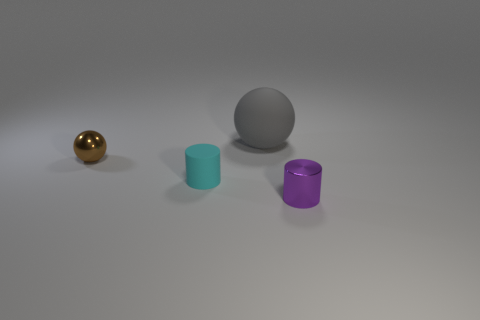The ball that is behind the tiny metallic ball is what color?
Your response must be concise. Gray. Does the tiny cyan cylinder have the same material as the cylinder to the right of the large gray matte object?
Provide a short and direct response. No. What is the material of the cyan object?
Ensure brevity in your answer.  Rubber. What is the shape of the other object that is made of the same material as the small purple thing?
Make the answer very short. Sphere. How many other things are the same shape as the brown thing?
Offer a terse response. 1. What number of gray objects are behind the purple shiny cylinder?
Your response must be concise. 1. Do the metallic object behind the metallic cylinder and the object behind the brown object have the same size?
Offer a very short reply. No. What number of other objects are there of the same size as the purple cylinder?
Keep it short and to the point. 2. There is a sphere right of the cyan matte cylinder in front of the tiny metal thing left of the small purple cylinder; what is it made of?
Provide a short and direct response. Rubber. Do the purple object and the sphere that is to the right of the tiny sphere have the same size?
Your response must be concise. No. 